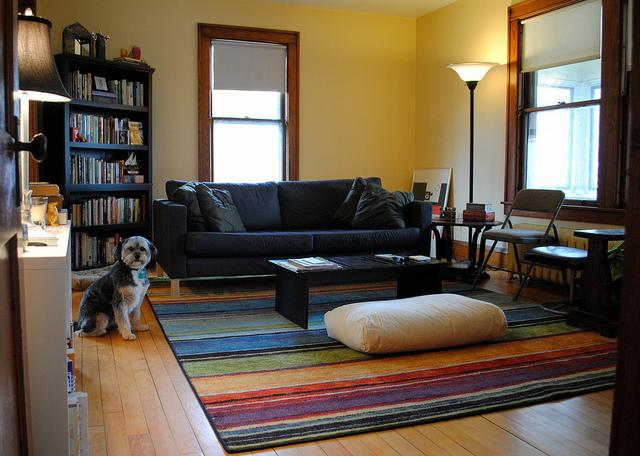What sound does the animal make? woof 